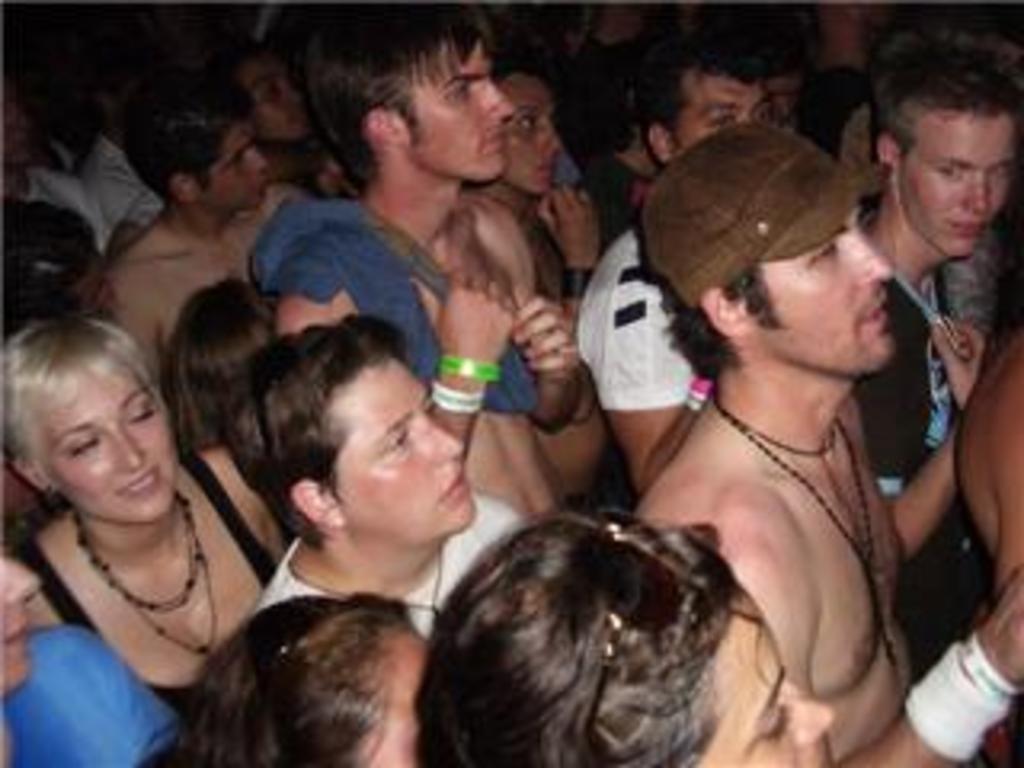Could you give a brief overview of what you see in this image? In the given image i can see a people. 